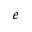<formula> <loc_0><loc_0><loc_500><loc_500>e</formula> 